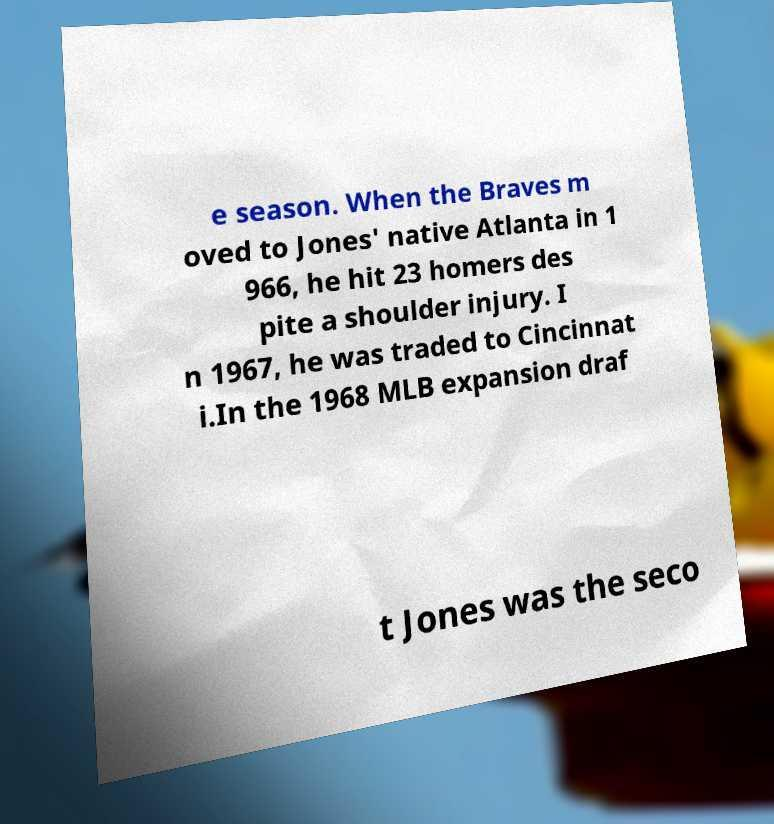What messages or text are displayed in this image? I need them in a readable, typed format. e season. When the Braves m oved to Jones' native Atlanta in 1 966, he hit 23 homers des pite a shoulder injury. I n 1967, he was traded to Cincinnat i.In the 1968 MLB expansion draf t Jones was the seco 